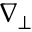<formula> <loc_0><loc_0><loc_500><loc_500>\nabla _ { \perp }</formula> 